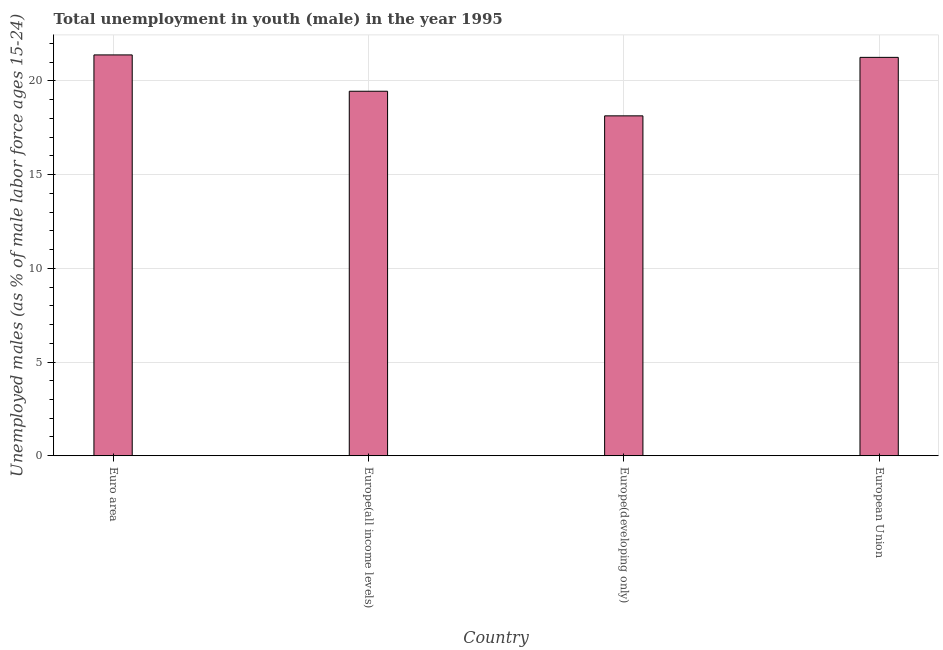What is the title of the graph?
Offer a very short reply. Total unemployment in youth (male) in the year 1995. What is the label or title of the X-axis?
Offer a terse response. Country. What is the label or title of the Y-axis?
Give a very brief answer. Unemployed males (as % of male labor force ages 15-24). What is the unemployed male youth population in European Union?
Give a very brief answer. 21.25. Across all countries, what is the maximum unemployed male youth population?
Offer a very short reply. 21.38. Across all countries, what is the minimum unemployed male youth population?
Offer a terse response. 18.13. In which country was the unemployed male youth population maximum?
Offer a very short reply. Euro area. In which country was the unemployed male youth population minimum?
Offer a very short reply. Europe(developing only). What is the sum of the unemployed male youth population?
Your answer should be very brief. 80.21. What is the difference between the unemployed male youth population in Europe(all income levels) and European Union?
Provide a short and direct response. -1.81. What is the average unemployed male youth population per country?
Make the answer very short. 20.05. What is the median unemployed male youth population?
Make the answer very short. 20.35. In how many countries, is the unemployed male youth population greater than 8 %?
Offer a very short reply. 4. What is the ratio of the unemployed male youth population in Euro area to that in Europe(developing only)?
Offer a very short reply. 1.18. Is the unemployed male youth population in Europe(all income levels) less than that in Europe(developing only)?
Give a very brief answer. No. What is the difference between the highest and the second highest unemployed male youth population?
Give a very brief answer. 0.13. Is the sum of the unemployed male youth population in Euro area and Europe(all income levels) greater than the maximum unemployed male youth population across all countries?
Give a very brief answer. Yes. What is the difference between the highest and the lowest unemployed male youth population?
Offer a very short reply. 3.25. How many countries are there in the graph?
Keep it short and to the point. 4. Are the values on the major ticks of Y-axis written in scientific E-notation?
Ensure brevity in your answer.  No. What is the Unemployed males (as % of male labor force ages 15-24) in Euro area?
Give a very brief answer. 21.38. What is the Unemployed males (as % of male labor force ages 15-24) in Europe(all income levels)?
Provide a succinct answer. 19.44. What is the Unemployed males (as % of male labor force ages 15-24) in Europe(developing only)?
Provide a succinct answer. 18.13. What is the Unemployed males (as % of male labor force ages 15-24) of European Union?
Provide a succinct answer. 21.25. What is the difference between the Unemployed males (as % of male labor force ages 15-24) in Euro area and Europe(all income levels)?
Your response must be concise. 1.94. What is the difference between the Unemployed males (as % of male labor force ages 15-24) in Euro area and Europe(developing only)?
Your response must be concise. 3.25. What is the difference between the Unemployed males (as % of male labor force ages 15-24) in Euro area and European Union?
Offer a very short reply. 0.13. What is the difference between the Unemployed males (as % of male labor force ages 15-24) in Europe(all income levels) and Europe(developing only)?
Your answer should be very brief. 1.31. What is the difference between the Unemployed males (as % of male labor force ages 15-24) in Europe(all income levels) and European Union?
Your answer should be very brief. -1.81. What is the difference between the Unemployed males (as % of male labor force ages 15-24) in Europe(developing only) and European Union?
Your response must be concise. -3.12. What is the ratio of the Unemployed males (as % of male labor force ages 15-24) in Euro area to that in Europe(all income levels)?
Your answer should be very brief. 1.1. What is the ratio of the Unemployed males (as % of male labor force ages 15-24) in Euro area to that in Europe(developing only)?
Keep it short and to the point. 1.18. What is the ratio of the Unemployed males (as % of male labor force ages 15-24) in Europe(all income levels) to that in Europe(developing only)?
Provide a short and direct response. 1.07. What is the ratio of the Unemployed males (as % of male labor force ages 15-24) in Europe(all income levels) to that in European Union?
Ensure brevity in your answer.  0.92. What is the ratio of the Unemployed males (as % of male labor force ages 15-24) in Europe(developing only) to that in European Union?
Ensure brevity in your answer.  0.85. 